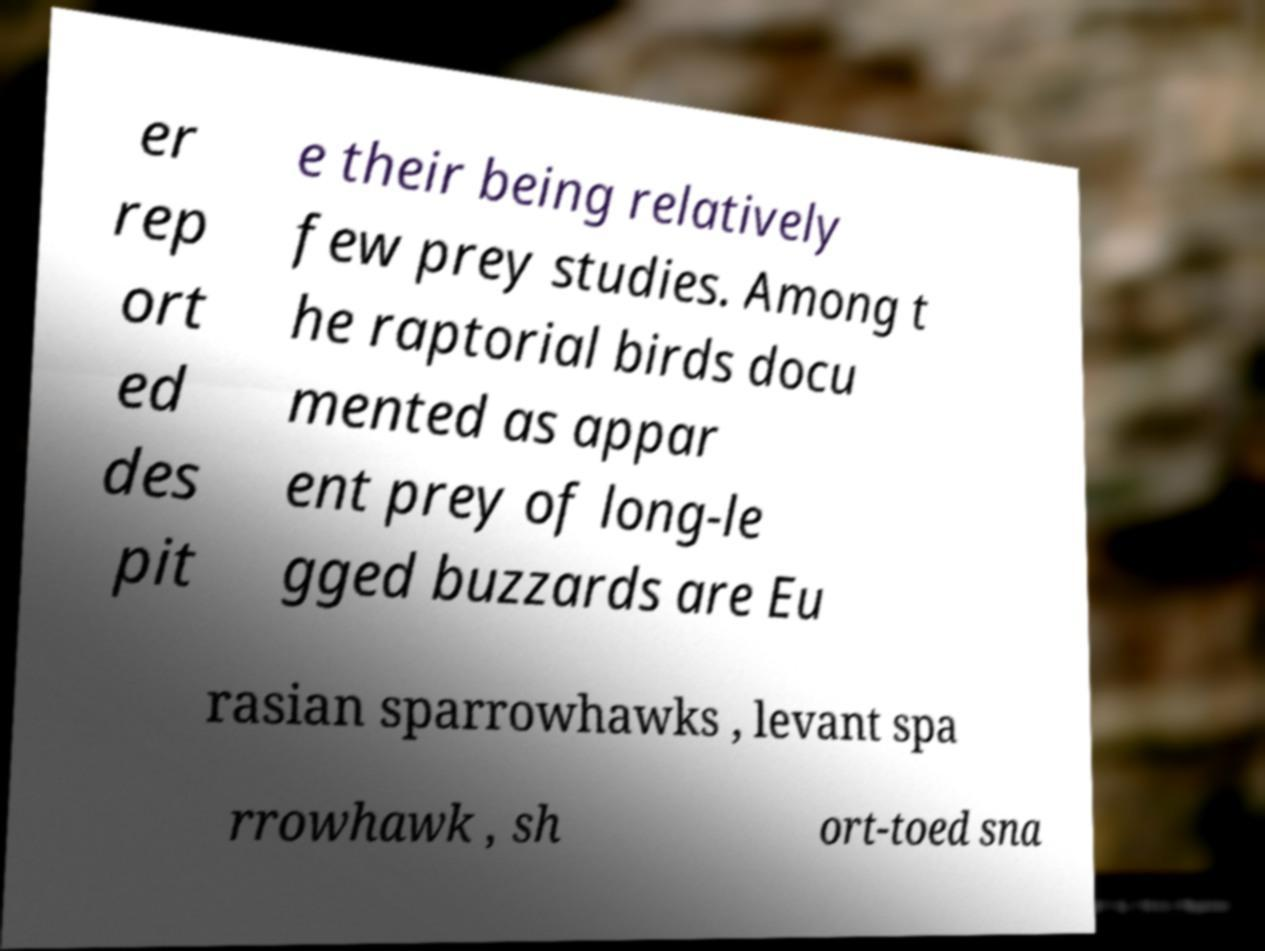I need the written content from this picture converted into text. Can you do that? er rep ort ed des pit e their being relatively few prey studies. Among t he raptorial birds docu mented as appar ent prey of long-le gged buzzards are Eu rasian sparrowhawks , levant spa rrowhawk , sh ort-toed sna 